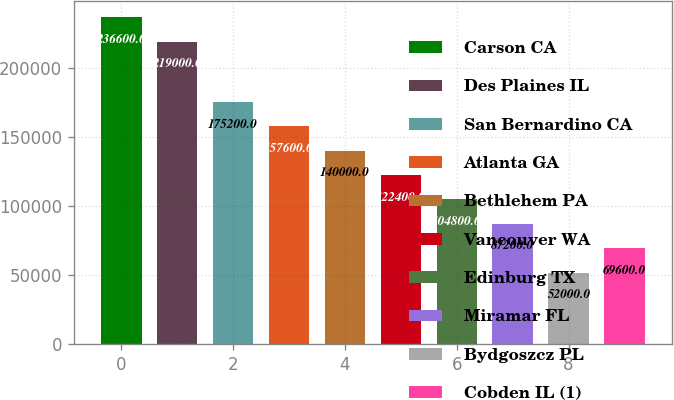Convert chart to OTSL. <chart><loc_0><loc_0><loc_500><loc_500><bar_chart><fcel>Carson CA<fcel>Des Plaines IL<fcel>San Bernardino CA<fcel>Atlanta GA<fcel>Bethlehem PA<fcel>Vancouver WA<fcel>Edinburg TX<fcel>Miramar FL<fcel>Bydgoszcz PL<fcel>Cobden IL (1)<nl><fcel>236600<fcel>219000<fcel>175200<fcel>157600<fcel>140000<fcel>122400<fcel>104800<fcel>87200<fcel>52000<fcel>69600<nl></chart> 